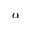<formula> <loc_0><loc_0><loc_500><loc_500>\alpha</formula> 